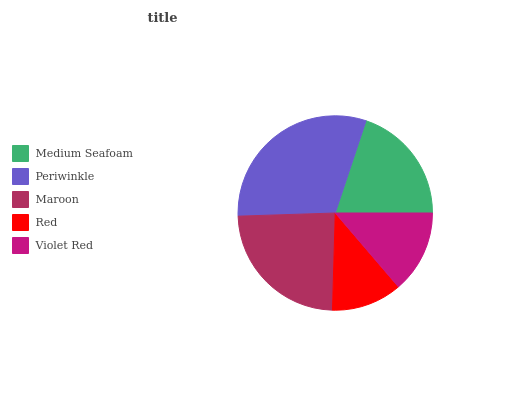Is Red the minimum?
Answer yes or no. Yes. Is Periwinkle the maximum?
Answer yes or no. Yes. Is Maroon the minimum?
Answer yes or no. No. Is Maroon the maximum?
Answer yes or no. No. Is Periwinkle greater than Maroon?
Answer yes or no. Yes. Is Maroon less than Periwinkle?
Answer yes or no. Yes. Is Maroon greater than Periwinkle?
Answer yes or no. No. Is Periwinkle less than Maroon?
Answer yes or no. No. Is Medium Seafoam the high median?
Answer yes or no. Yes. Is Medium Seafoam the low median?
Answer yes or no. Yes. Is Violet Red the high median?
Answer yes or no. No. Is Violet Red the low median?
Answer yes or no. No. 